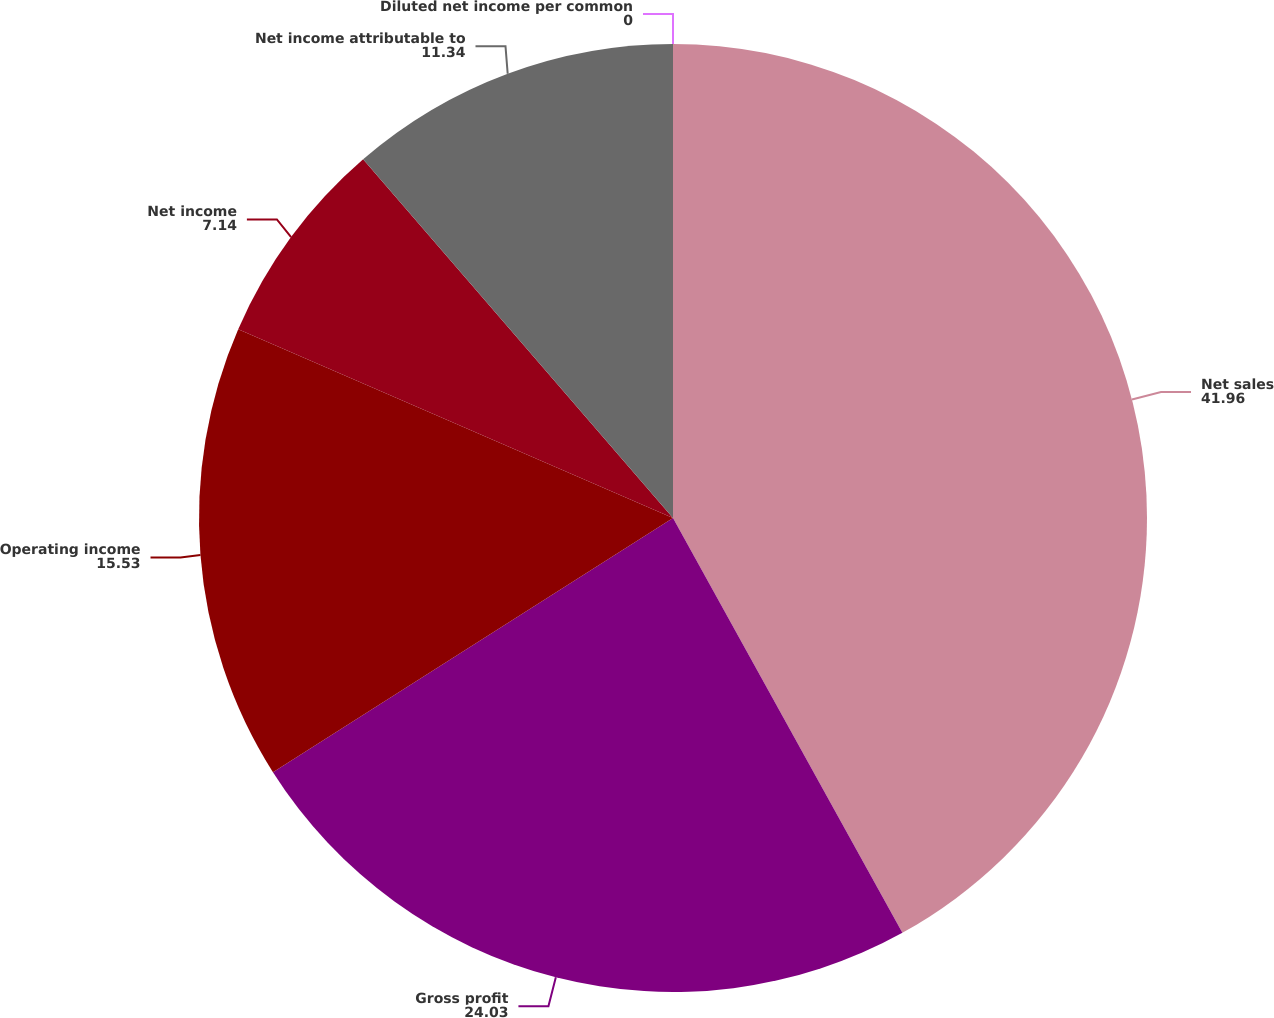Convert chart. <chart><loc_0><loc_0><loc_500><loc_500><pie_chart><fcel>Net sales<fcel>Gross profit<fcel>Operating income<fcel>Net income<fcel>Net income attributable to<fcel>Diluted net income per common<nl><fcel>41.96%<fcel>24.03%<fcel>15.53%<fcel>7.14%<fcel>11.34%<fcel>0.0%<nl></chart> 